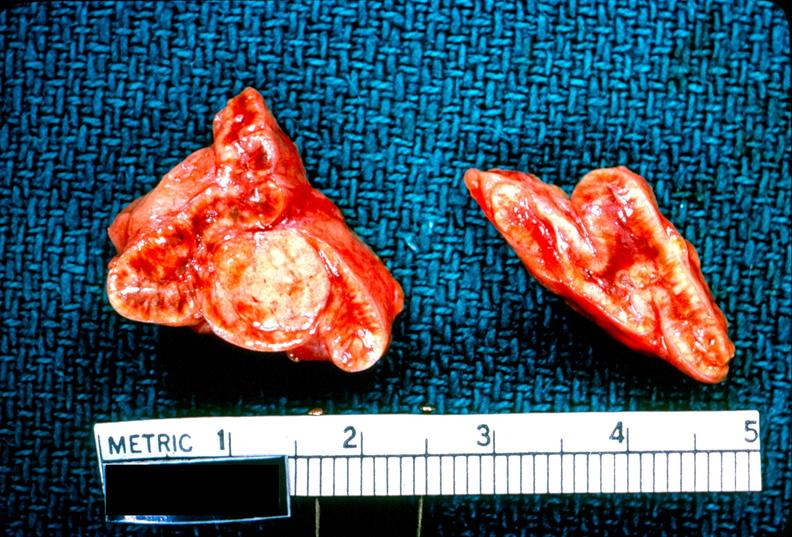what is present?
Answer the question using a single word or phrase. Endocrine 